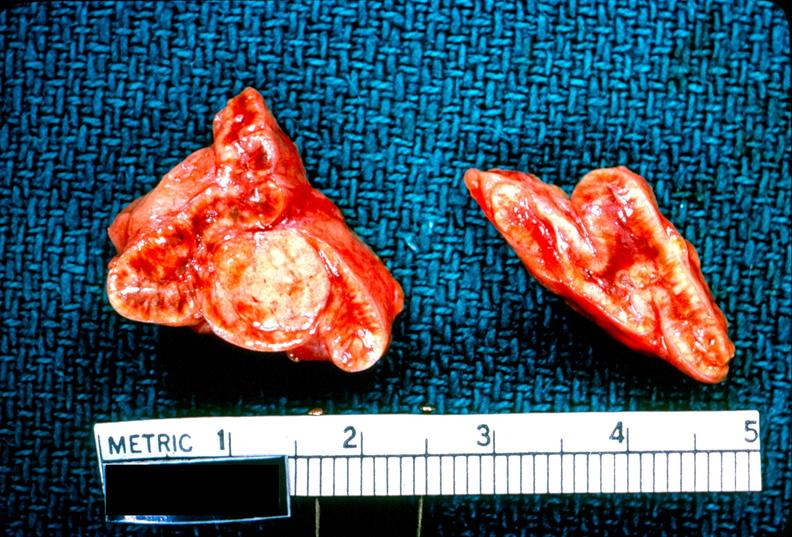what is present?
Answer the question using a single word or phrase. Endocrine 